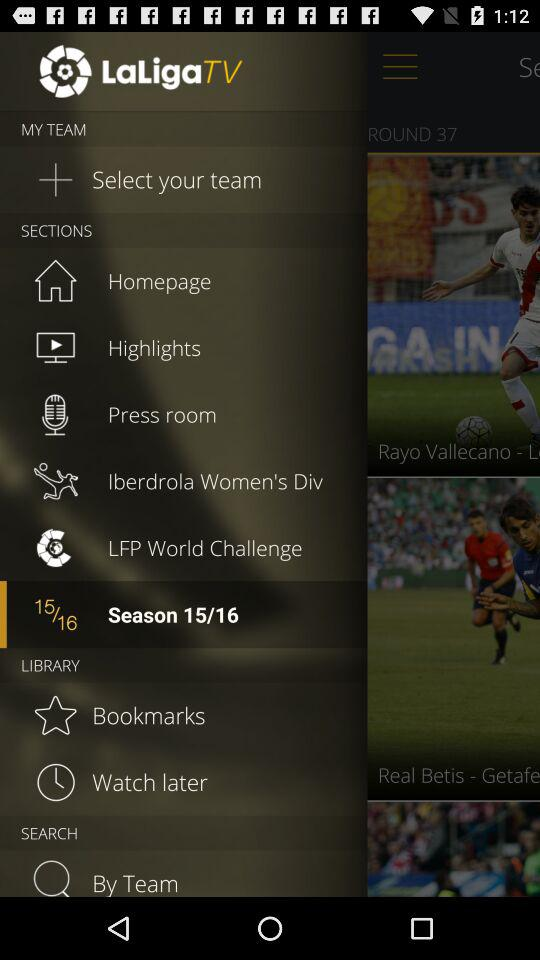How many seasons remain?
When the provided information is insufficient, respond with <no answer>. <no answer> 